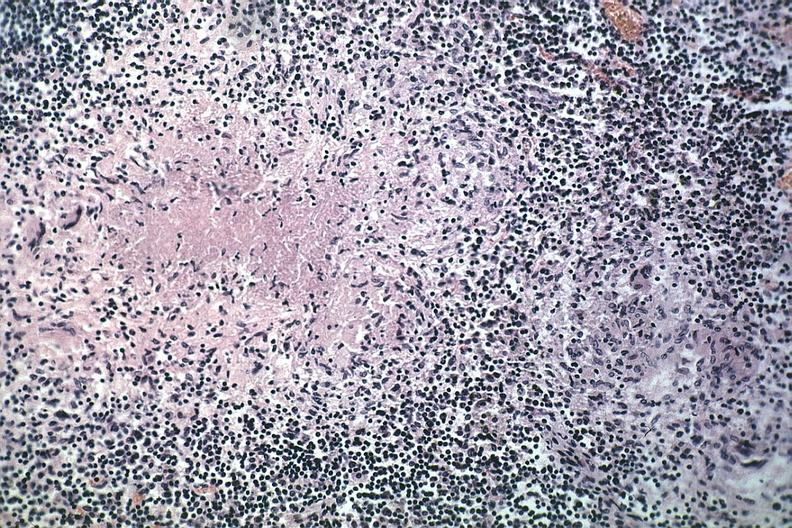s immunostain for growth hormone present?
Answer the question using a single word or phrase. No 